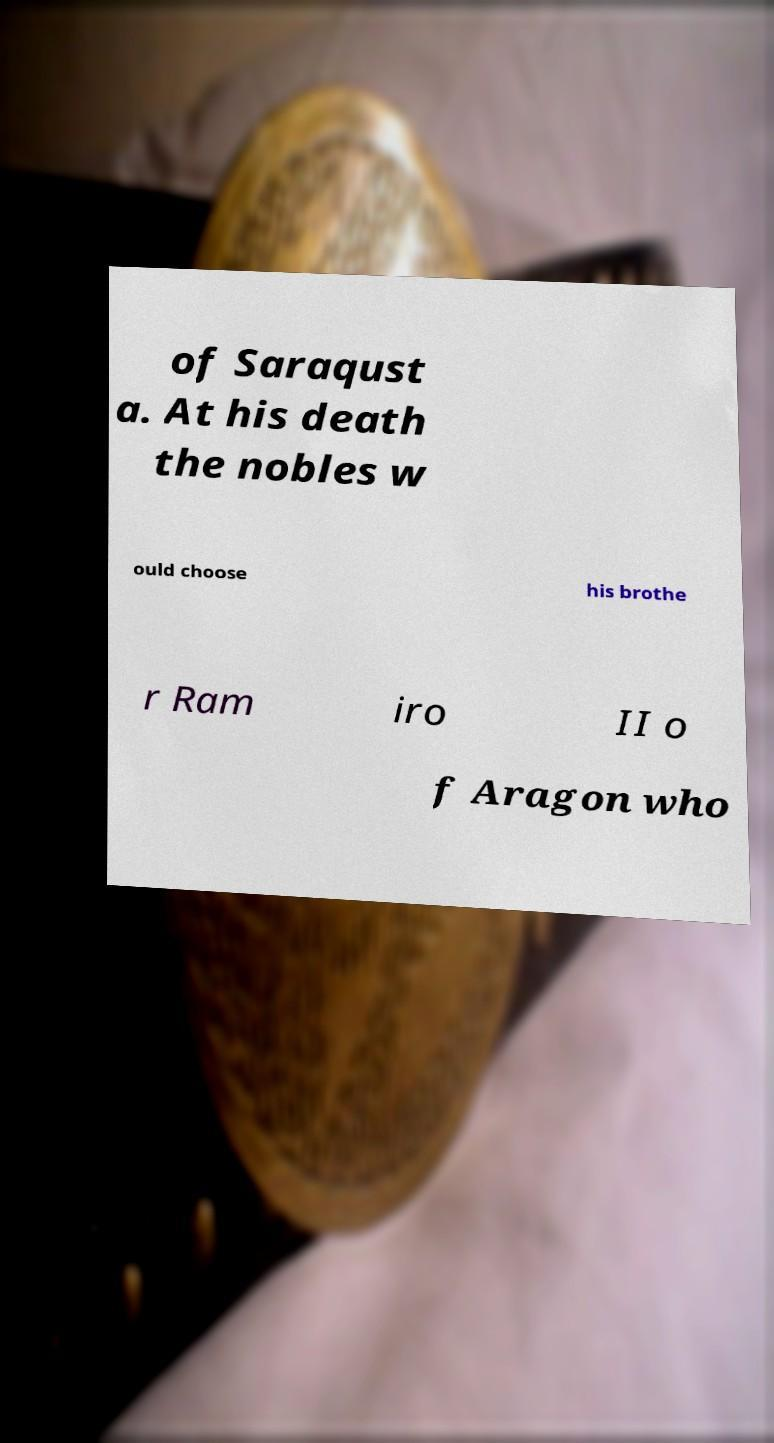Can you accurately transcribe the text from the provided image for me? of Saraqust a. At his death the nobles w ould choose his brothe r Ram iro II o f Aragon who 